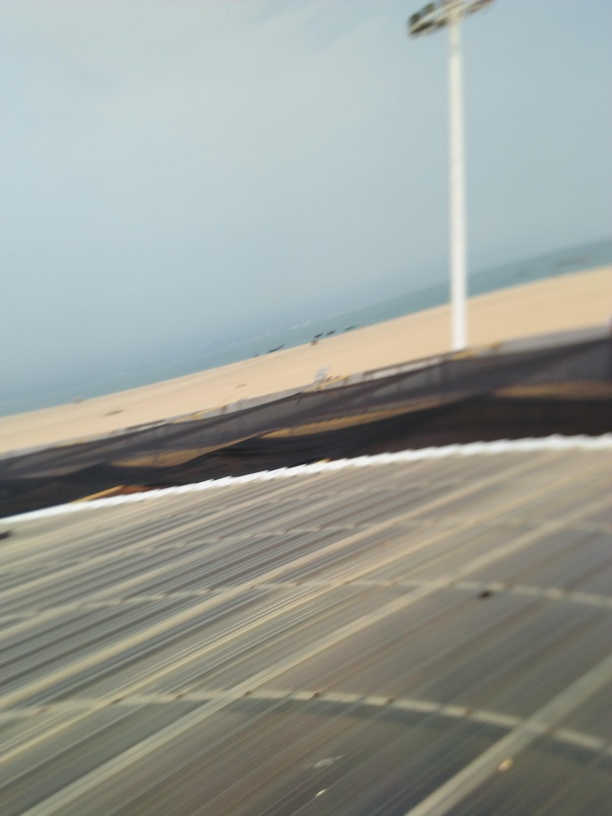What caused a loss of texture details in the image? The loss of texture detail in the image can most likely be attributed to motion blur, which occurs when the camera or subject moves during the exposure. In this particular image, the blurring pattern suggests that the camera was likely in motion, rather than the subject. The streaking of lines and the smearing of light and color are consistent with what we expect to see with camera motion, which leads to a decrease in sharpness and the specific textured details of the scenery being captured. While a couple of other factors could potentially contribute to a lesser extent, such as certain camera settings or lighting conditions, the primary culprit here appears to be motion blur. 